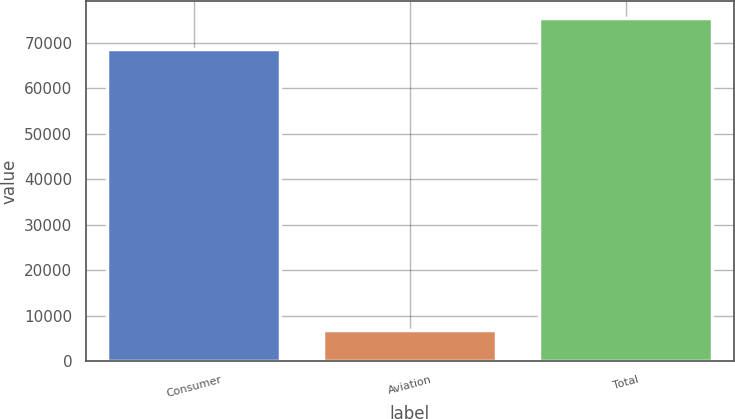Convert chart to OTSL. <chart><loc_0><loc_0><loc_500><loc_500><bar_chart><fcel>Consumer<fcel>Aviation<fcel>Total<nl><fcel>68609<fcel>6876<fcel>75485<nl></chart> 